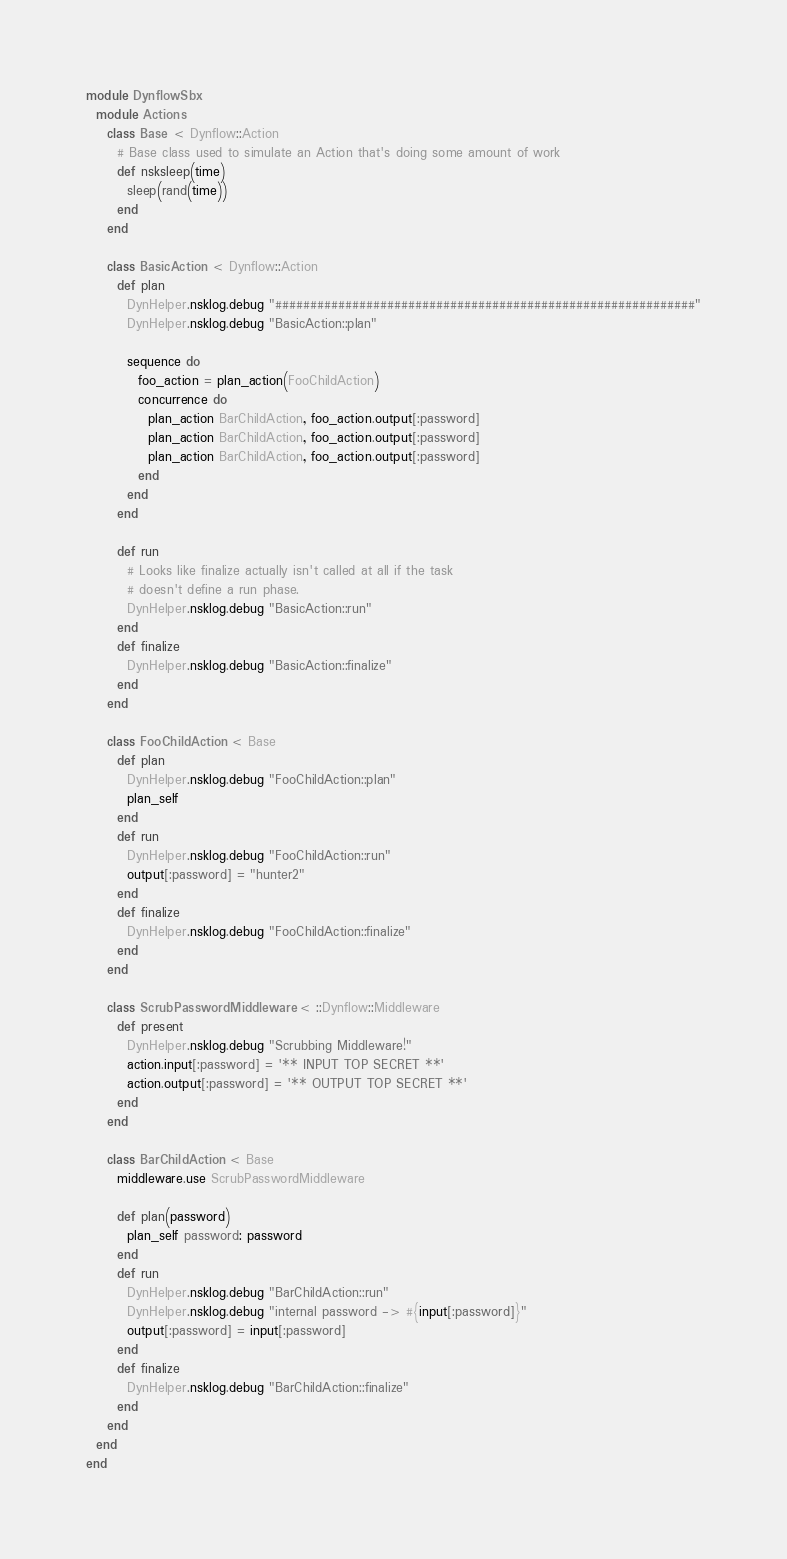Convert code to text. <code><loc_0><loc_0><loc_500><loc_500><_Ruby_>module DynflowSbx
  module Actions
    class Base < Dynflow::Action
      # Base class used to simulate an Action that's doing some amount of work
      def nsksleep(time)
        sleep(rand(time))
      end
    end

    class BasicAction < Dynflow::Action
      def plan
        DynHelper.nsklog.debug "############################################################"
        DynHelper.nsklog.debug "BasicAction::plan"

        sequence do
          foo_action = plan_action(FooChildAction)
          concurrence do
            plan_action BarChildAction, foo_action.output[:password]
            plan_action BarChildAction, foo_action.output[:password]
            plan_action BarChildAction, foo_action.output[:password]
          end
        end
      end

      def run
        # Looks like finalize actually isn't called at all if the task
        # doesn't define a run phase.
        DynHelper.nsklog.debug "BasicAction::run"
      end
      def finalize
        DynHelper.nsklog.debug "BasicAction::finalize"
      end
    end

    class FooChildAction < Base
      def plan
        DynHelper.nsklog.debug "FooChildAction::plan"
        plan_self
      end
      def run
        DynHelper.nsklog.debug "FooChildAction::run"
        output[:password] = "hunter2"
      end
      def finalize
        DynHelper.nsklog.debug "FooChildAction::finalize"
      end
    end

    class ScrubPasswordMiddleware < ::Dynflow::Middleware
      def present
        DynHelper.nsklog.debug "Scrubbing Middleware!"
        action.input[:password] = '** INPUT TOP SECRET **'
        action.output[:password] = '** OUTPUT TOP SECRET **'
      end
    end

    class BarChildAction < Base
      middleware.use ScrubPasswordMiddleware

      def plan(password)
        plan_self password: password
      end
      def run
        DynHelper.nsklog.debug "BarChildAction::run"
        DynHelper.nsklog.debug "internal password -> #{input[:password]}"
        output[:password] = input[:password]
      end
      def finalize
        DynHelper.nsklog.debug "BarChildAction::finalize"
      end
    end
  end
end
</code> 